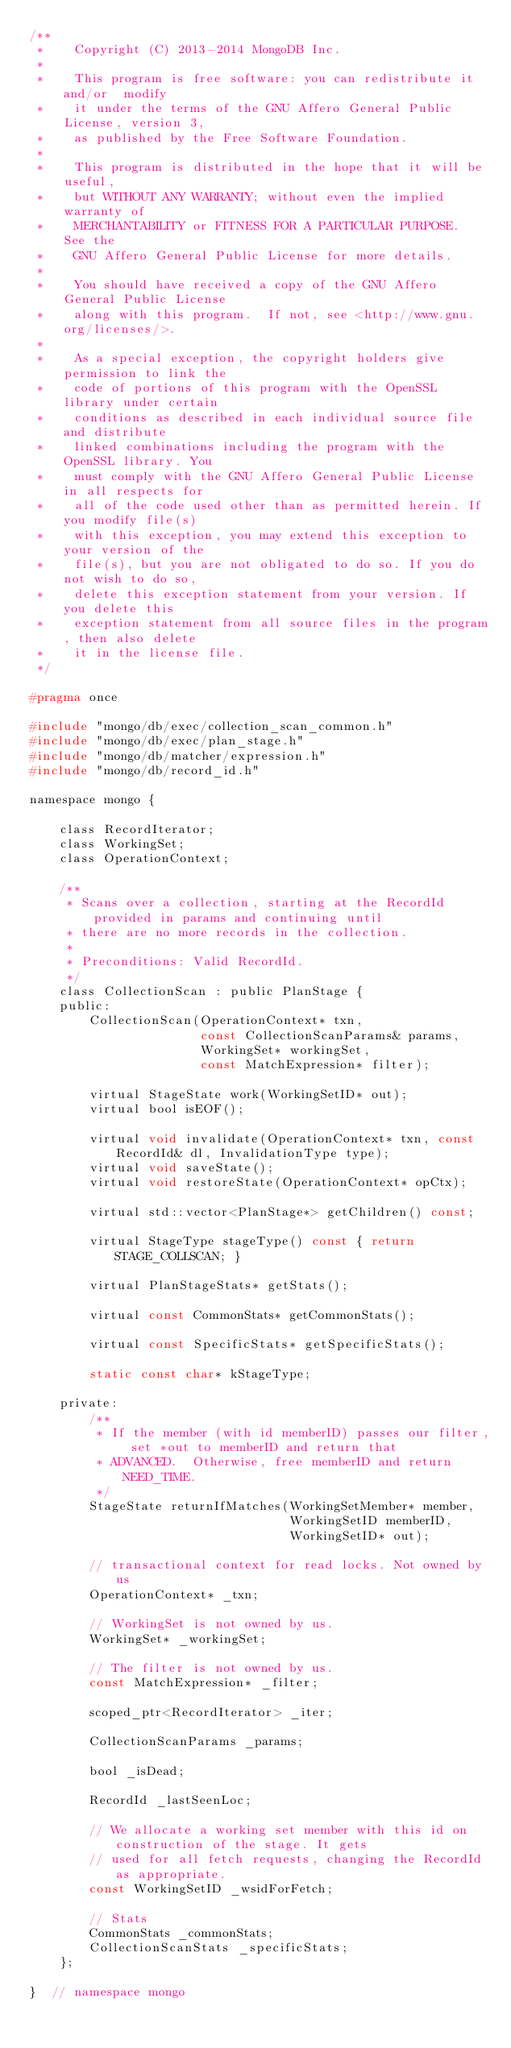<code> <loc_0><loc_0><loc_500><loc_500><_C_>/**
 *    Copyright (C) 2013-2014 MongoDB Inc.
 *
 *    This program is free software: you can redistribute it and/or  modify
 *    it under the terms of the GNU Affero General Public License, version 3,
 *    as published by the Free Software Foundation.
 *
 *    This program is distributed in the hope that it will be useful,
 *    but WITHOUT ANY WARRANTY; without even the implied warranty of
 *    MERCHANTABILITY or FITNESS FOR A PARTICULAR PURPOSE.  See the
 *    GNU Affero General Public License for more details.
 *
 *    You should have received a copy of the GNU Affero General Public License
 *    along with this program.  If not, see <http://www.gnu.org/licenses/>.
 *
 *    As a special exception, the copyright holders give permission to link the
 *    code of portions of this program with the OpenSSL library under certain
 *    conditions as described in each individual source file and distribute
 *    linked combinations including the program with the OpenSSL library. You
 *    must comply with the GNU Affero General Public License in all respects for
 *    all of the code used other than as permitted herein. If you modify file(s)
 *    with this exception, you may extend this exception to your version of the
 *    file(s), but you are not obligated to do so. If you do not wish to do so,
 *    delete this exception statement from your version. If you delete this
 *    exception statement from all source files in the program, then also delete
 *    it in the license file.
 */

#pragma once

#include "mongo/db/exec/collection_scan_common.h"
#include "mongo/db/exec/plan_stage.h"
#include "mongo/db/matcher/expression.h"
#include "mongo/db/record_id.h"

namespace mongo {

    class RecordIterator;
    class WorkingSet;
    class OperationContext;

    /**
     * Scans over a collection, starting at the RecordId provided in params and continuing until
     * there are no more records in the collection.
     *
     * Preconditions: Valid RecordId.
     */
    class CollectionScan : public PlanStage {
    public:
        CollectionScan(OperationContext* txn,
                       const CollectionScanParams& params,
                       WorkingSet* workingSet,
                       const MatchExpression* filter);

        virtual StageState work(WorkingSetID* out);
        virtual bool isEOF();

        virtual void invalidate(OperationContext* txn, const RecordId& dl, InvalidationType type);
        virtual void saveState();
        virtual void restoreState(OperationContext* opCtx);

        virtual std::vector<PlanStage*> getChildren() const;

        virtual StageType stageType() const { return STAGE_COLLSCAN; }

        virtual PlanStageStats* getStats();

        virtual const CommonStats* getCommonStats();

        virtual const SpecificStats* getSpecificStats();

        static const char* kStageType;

    private:
        /**
         * If the member (with id memberID) passes our filter, set *out to memberID and return that
         * ADVANCED.  Otherwise, free memberID and return NEED_TIME.
         */
        StageState returnIfMatches(WorkingSetMember* member,
                                   WorkingSetID memberID,
                                   WorkingSetID* out);

        // transactional context for read locks. Not owned by us
        OperationContext* _txn;

        // WorkingSet is not owned by us.
        WorkingSet* _workingSet;

        // The filter is not owned by us.
        const MatchExpression* _filter;

        scoped_ptr<RecordIterator> _iter;

        CollectionScanParams _params;

        bool _isDead;

        RecordId _lastSeenLoc;

        // We allocate a working set member with this id on construction of the stage. It gets
        // used for all fetch requests, changing the RecordId as appropriate.
        const WorkingSetID _wsidForFetch;

        // Stats
        CommonStats _commonStats;
        CollectionScanStats _specificStats;
    };

}  // namespace mongo
</code> 